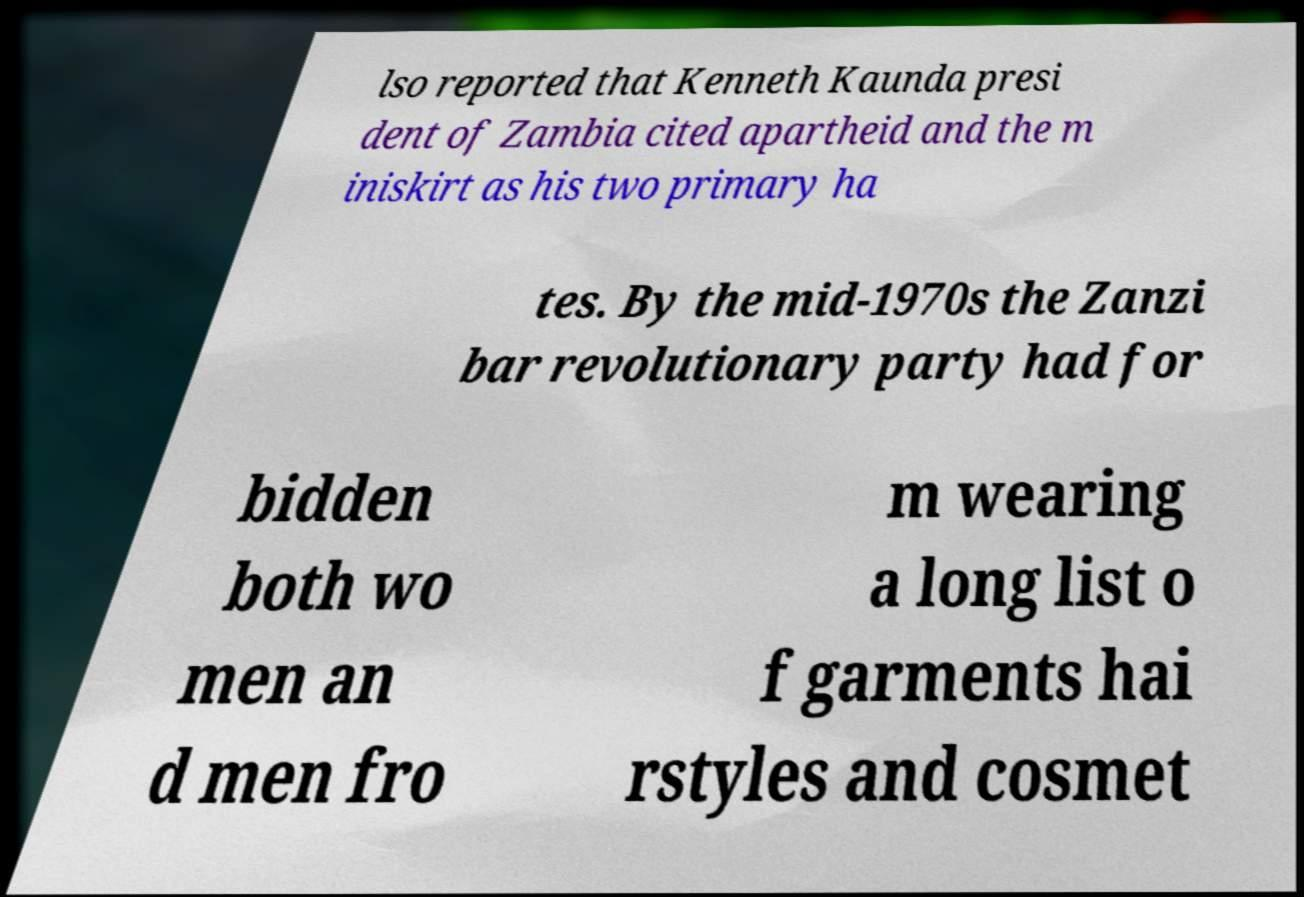What messages or text are displayed in this image? I need them in a readable, typed format. lso reported that Kenneth Kaunda presi dent of Zambia cited apartheid and the m iniskirt as his two primary ha tes. By the mid-1970s the Zanzi bar revolutionary party had for bidden both wo men an d men fro m wearing a long list o f garments hai rstyles and cosmet 